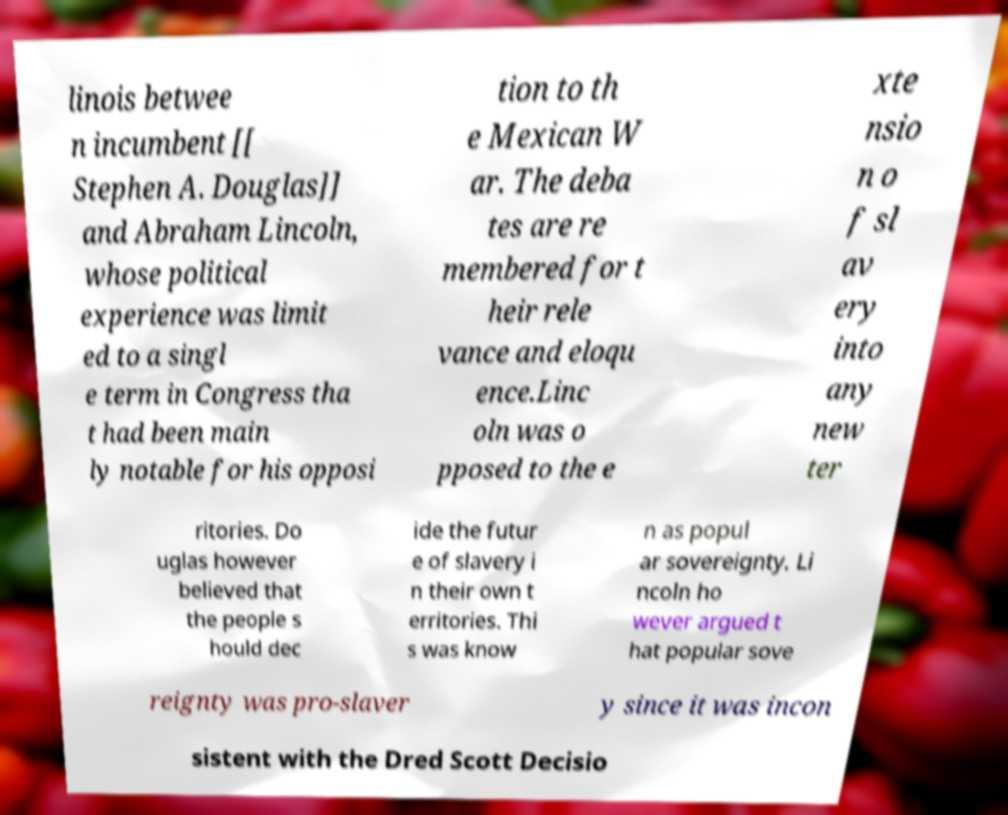For documentation purposes, I need the text within this image transcribed. Could you provide that? linois betwee n incumbent [[ Stephen A. Douglas]] and Abraham Lincoln, whose political experience was limit ed to a singl e term in Congress tha t had been main ly notable for his opposi tion to th e Mexican W ar. The deba tes are re membered for t heir rele vance and eloqu ence.Linc oln was o pposed to the e xte nsio n o f sl av ery into any new ter ritories. Do uglas however believed that the people s hould dec ide the futur e of slavery i n their own t erritories. Thi s was know n as popul ar sovereignty. Li ncoln ho wever argued t hat popular sove reignty was pro-slaver y since it was incon sistent with the Dred Scott Decisio 